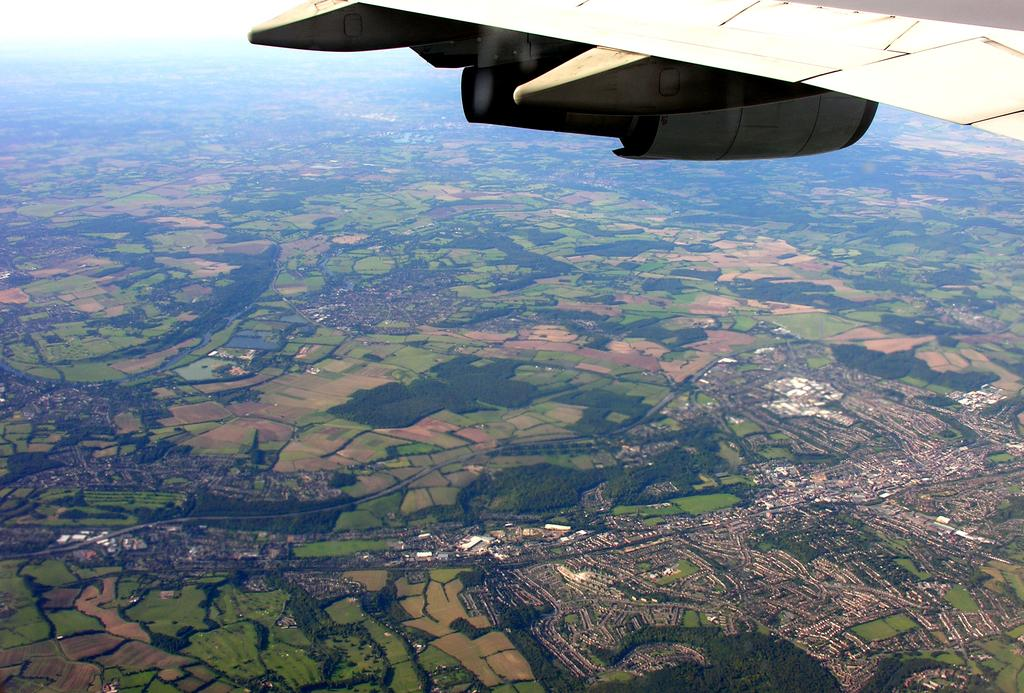What type of view is shown in the image? The image is an aerial view. What natural elements can be seen in the image? There are trees visible in the image. What man-made structures can be seen in the image? There are buildings visible in the image. Can you identify any part of an airplane in the image? Yes, there is an airplane wing in the top right corner of the image. Where is the snake hiding in the image? There is no snake present in the image. What type of horn can be seen on the buildings in the image? There are no horns visible on the buildings in the image. 